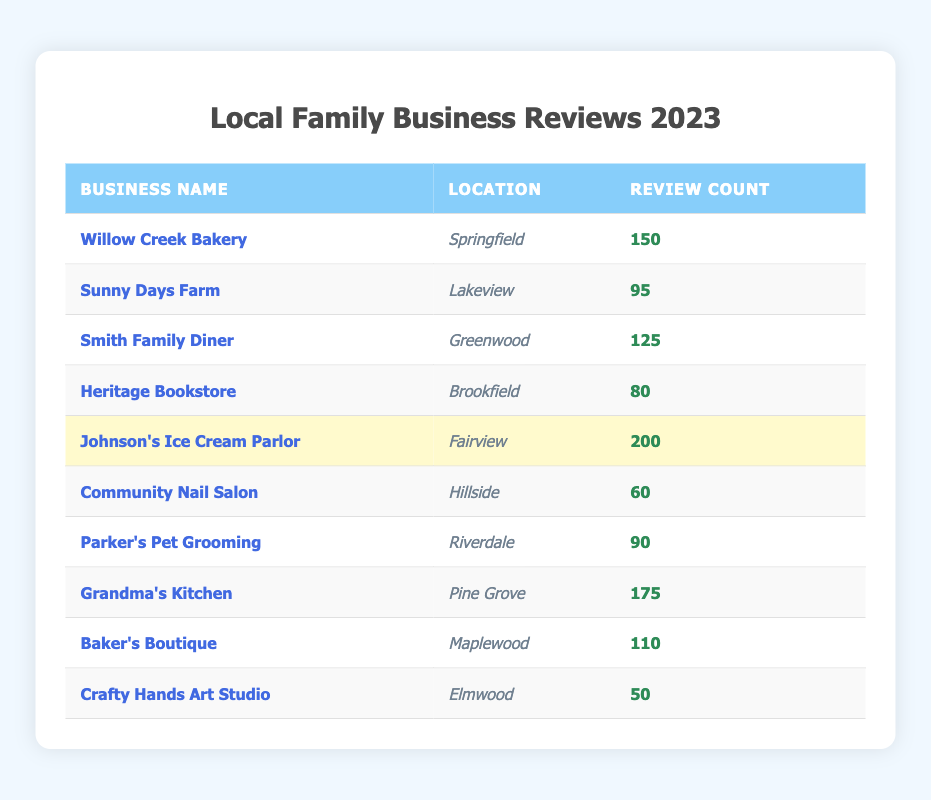What is the review count for Johnson's Ice Cream Parlor? The table shows that Johnson's Ice Cream Parlor has a review count of 200.
Answer: 200 Which family business has the lowest number of reviews? The table indicates that Crafty Hands Art Studio has the lowest review count at 50.
Answer: Crafty Hands Art Studio What is the total number of reviews for Grandma's Kitchen and Smith Family Diner combined? Grandma's Kitchen has 175 reviews and Smith Family Diner has 125 reviews. Combining these gives 175 + 125 = 300.
Answer: 300 Is it true that Willow Creek Bakery has more reviews than Sunny Days Farm? Comparing the review counts, Willow Creek Bakery has 150 reviews and Sunny Days Farm has 95 reviews, thus the statement is true.
Answer: Yes Which business has more reviews: Parker's Pet Grooming or Community Nail Salon? Parker's Pet Grooming has 90 reviews, while Community Nail Salon has 60. Therefore, Parker's Pet Grooming has more.
Answer: Parker's Pet Grooming What is the average review count of all the listed businesses? To calculate the average, sum all the reviews: (150 + 95 + 125 + 80 + 200 + 60 + 90 + 175 + 110 + 50) = 1,130. Then, divide by the number of businesses (10): 1,130/10 = 113.
Answer: 113 If we consider only the businesses with more than 100 reviews, how many are there? The businesses with more than 100 reviews are Johnson's Ice Cream Parlor (200), Grandma's Kitchen (175), Willow Creek Bakery (150), and Smith Family Diner (125). This gives a total of 4 businesses.
Answer: 4 What is the difference in review counts between the highest and lowest-rated businesses? The highest-rated business is Johnson's Ice Cream Parlor with 200 reviews, and the lowest is Crafty Hands Art Studio with 50 reviews. The difference is 200 - 50 = 150.
Answer: 150 Which location has the most reviews and what is its review count? Johnson's Ice Cream Parlor is in Fairview and has the highest review count of 200.
Answer: Fairview, 200 What percentage of total reviews does Sunny Days Farm represent? Sunny Days Farm has 95 reviews. The total number of reviews is 1,130. Thus, the percentage is (95/1,130) * 100 ≈ 8.39%.
Answer: 8.39% 